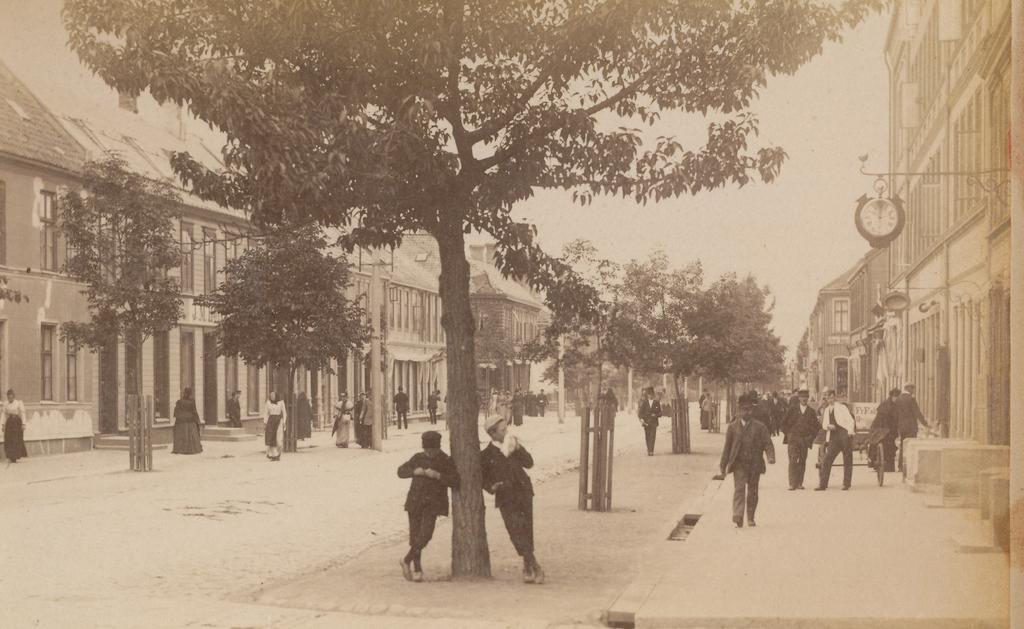In one or two sentences, can you explain what this image depicts? This is the picture of a city. In this image there are group of people. In this image there are buildings and trees. On the right side of the image there is a clock on the building and there is a vehicle on the footpath. 